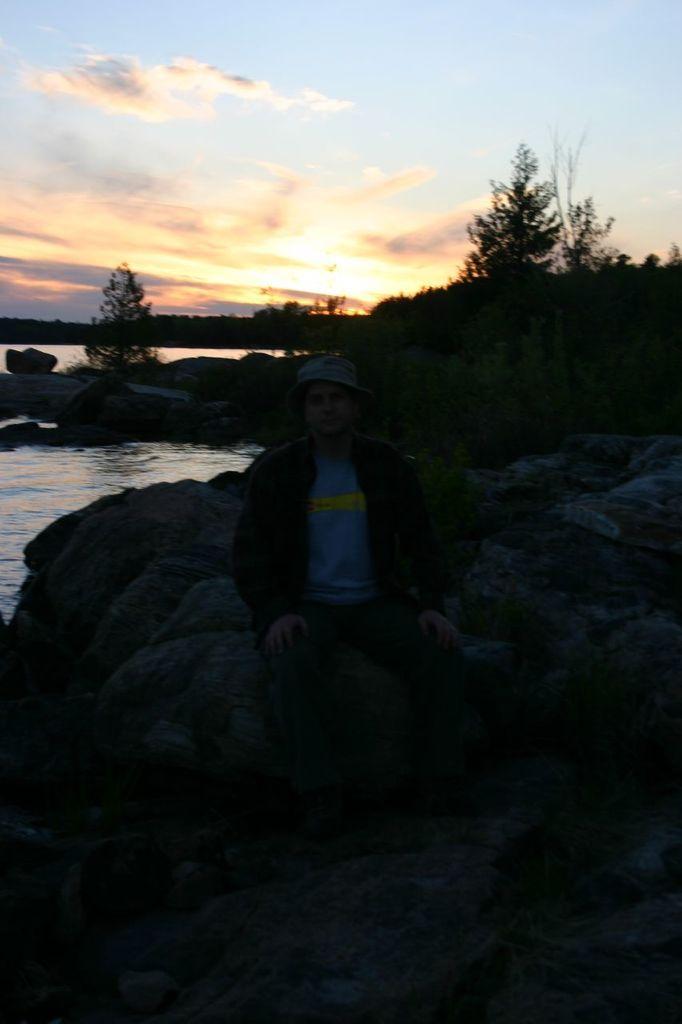Can you describe this image briefly? In this picture we can see a person sitting on a rock. There are few trees in the background. Sky is cloudy. 